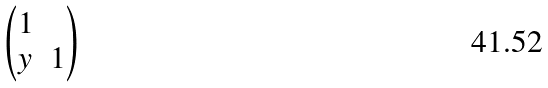<formula> <loc_0><loc_0><loc_500><loc_500>\begin{pmatrix} 1 & \\ y & 1 \end{pmatrix}</formula> 